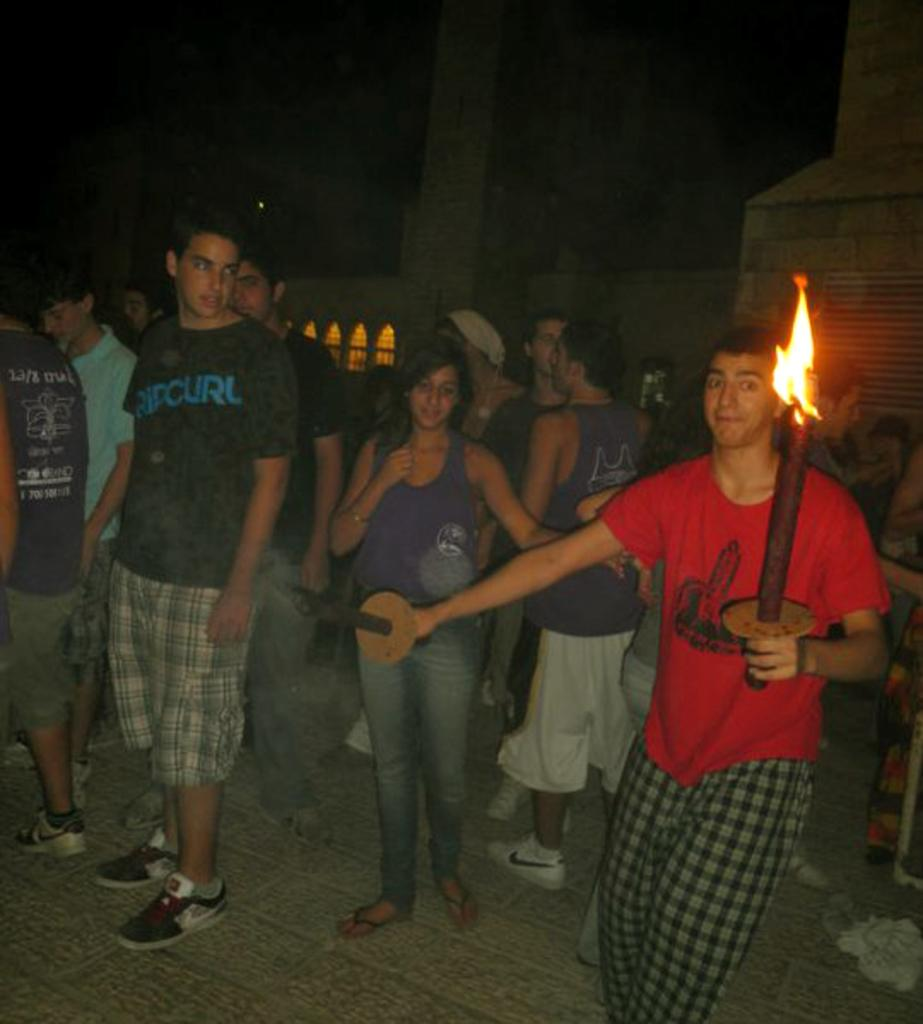How many people are in the image? There are persons standing in the image. What is one person holding in the image? One person is holding an object. What else is the person holding besides the object? The person holding the object is also holding a fire lamp. What can be seen in the background of the image? There is a building visible in the background of the image. Is there an island visible in the image? There is no island present in the image. What type of business is being conducted in the image? The image does not depict any business activities. 